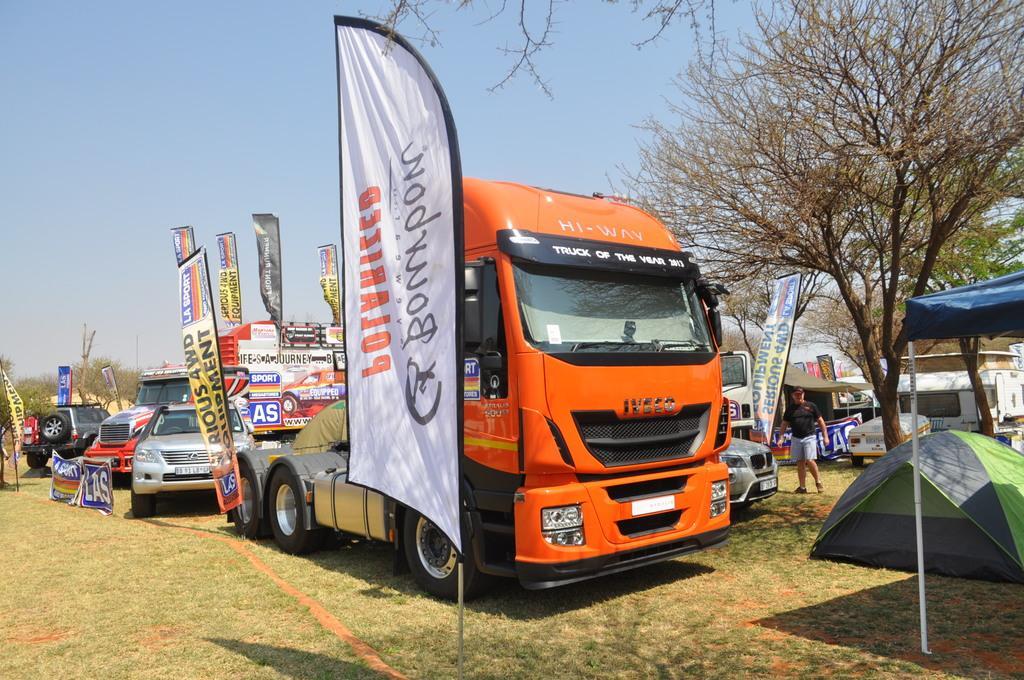Can you describe this image briefly? This picture is clicked outside. In the center we can see the group of vehicles parked on the ground and we can see the tents and the person walking on the ground and there are many number of banners on which we can see the text is printed and there are some objects. In the background there is a sky and the trees. 